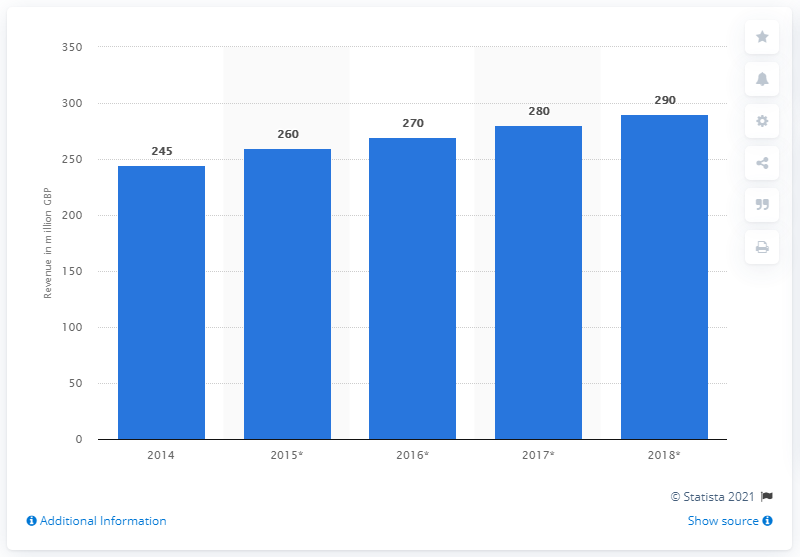What could be the reason behind the steady increase in revenue? Various factors might contribute to this steady increase in revenue, such as expansion into new markets, successful marketing strategies, product innovations, or overall industry growth. Detailed financial reports would offer more insight into the specific reasons for this company's revenue trend. 